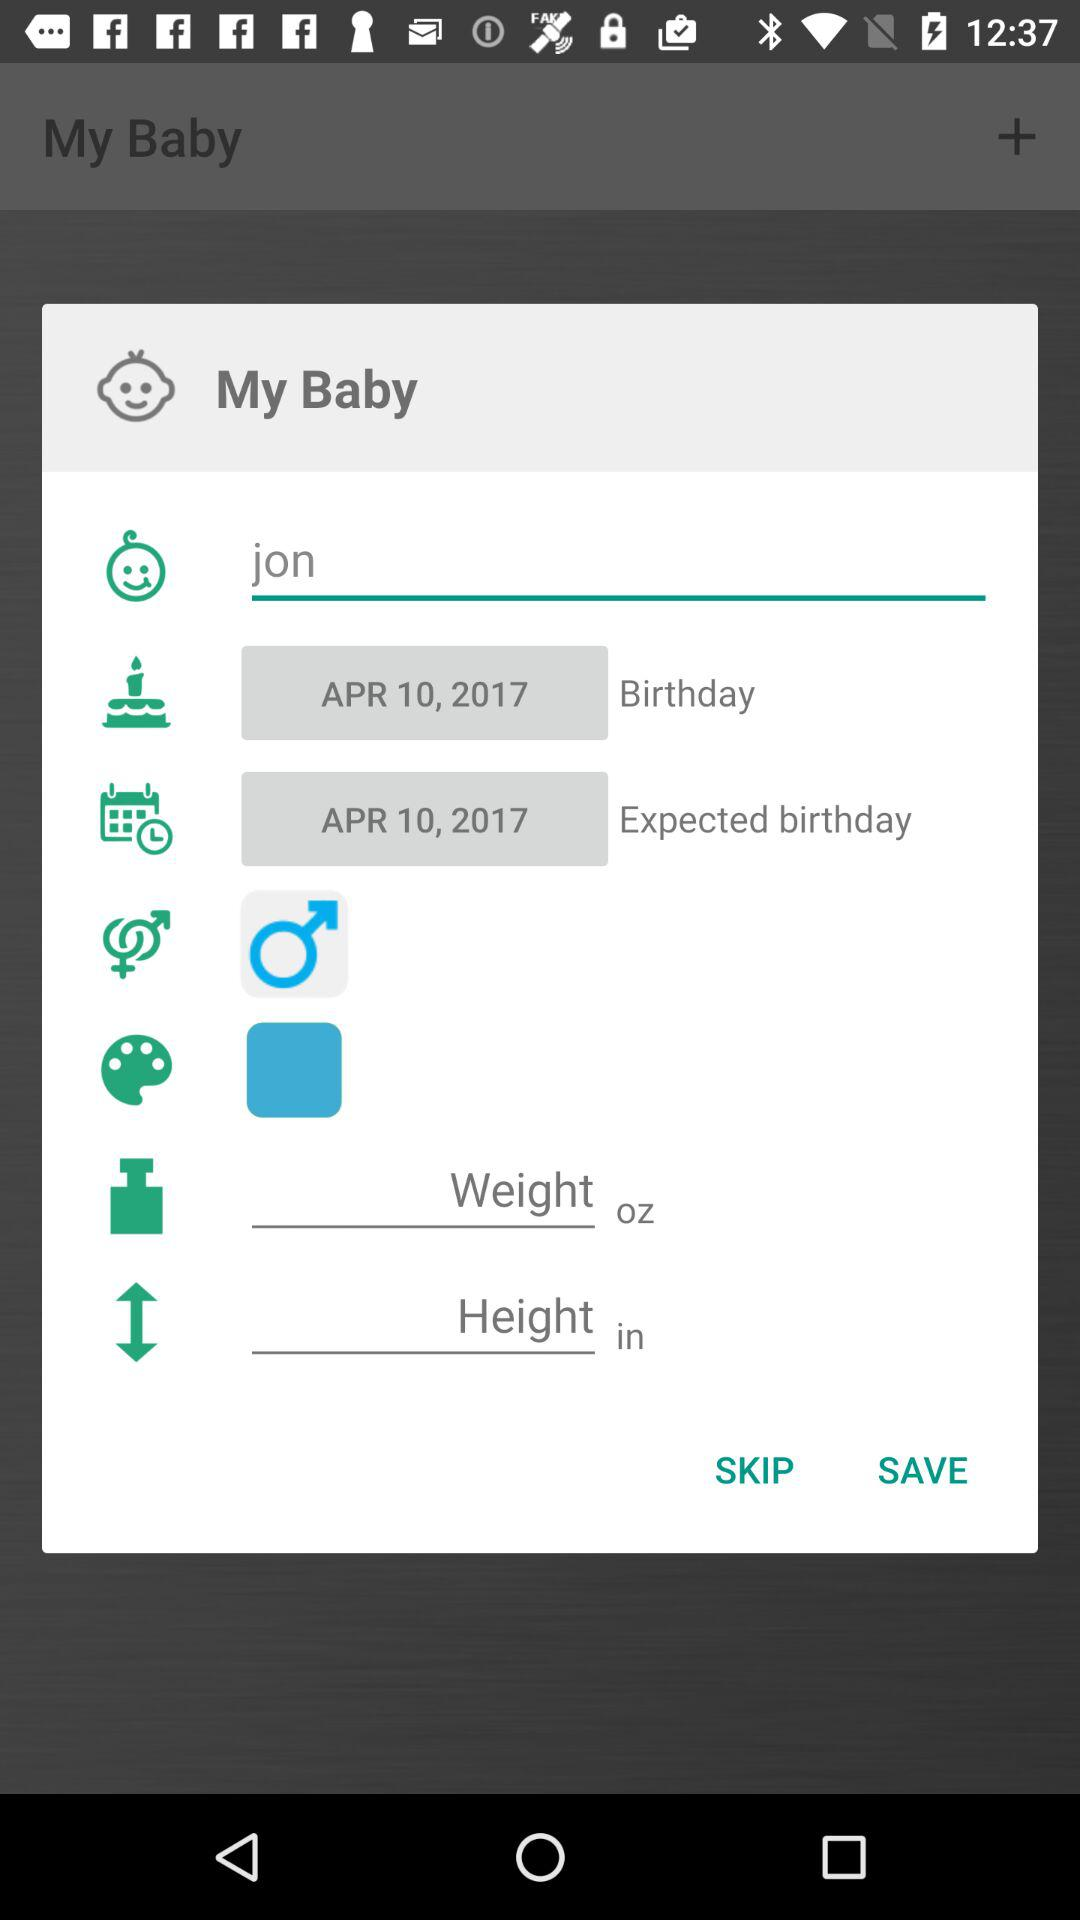What is the baby's name? The baby's name is Jon. 